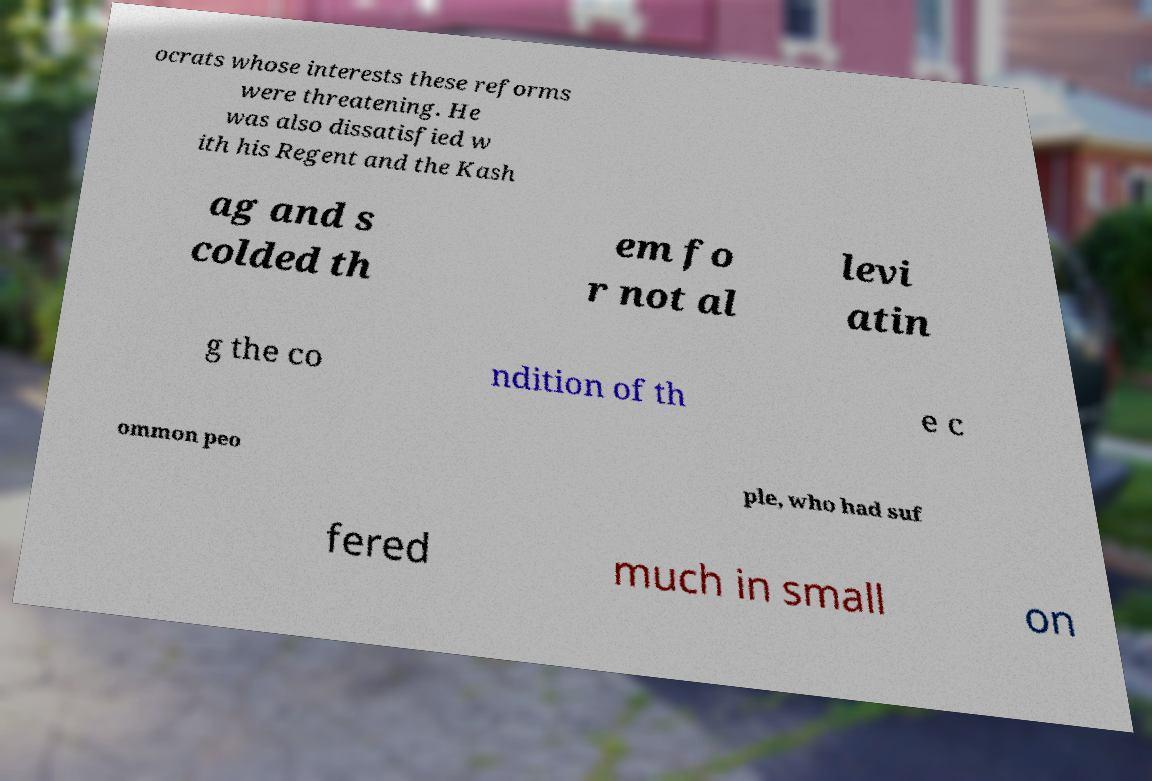Please read and relay the text visible in this image. What does it say? ocrats whose interests these reforms were threatening. He was also dissatisfied w ith his Regent and the Kash ag and s colded th em fo r not al levi atin g the co ndition of th e c ommon peo ple, who had suf fered much in small on 